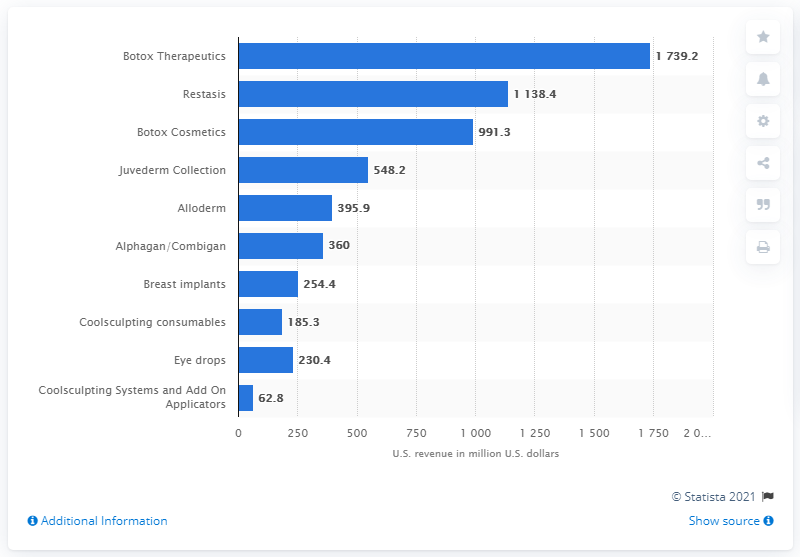List a handful of essential elements in this visual. In 2019, Botox Therapeutics was the top specialty product. 